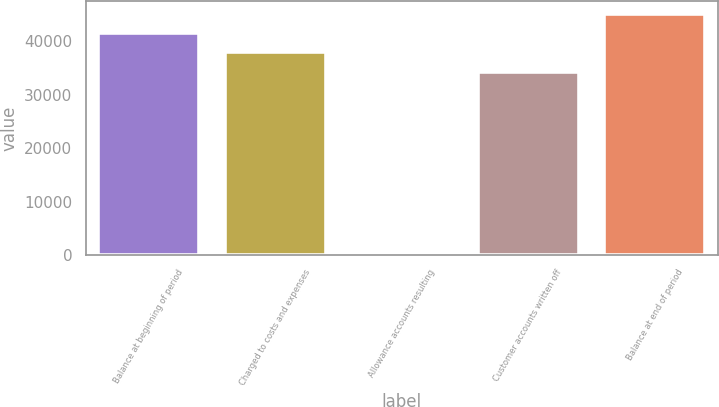Convert chart. <chart><loc_0><loc_0><loc_500><loc_500><bar_chart><fcel>Balance at beginning of period<fcel>Charged to costs and expenses<fcel>Allowance accounts resulting<fcel>Customer accounts written off<fcel>Balance at end of period<nl><fcel>41583.8<fcel>37940.4<fcel>139<fcel>34297<fcel>45227.2<nl></chart> 